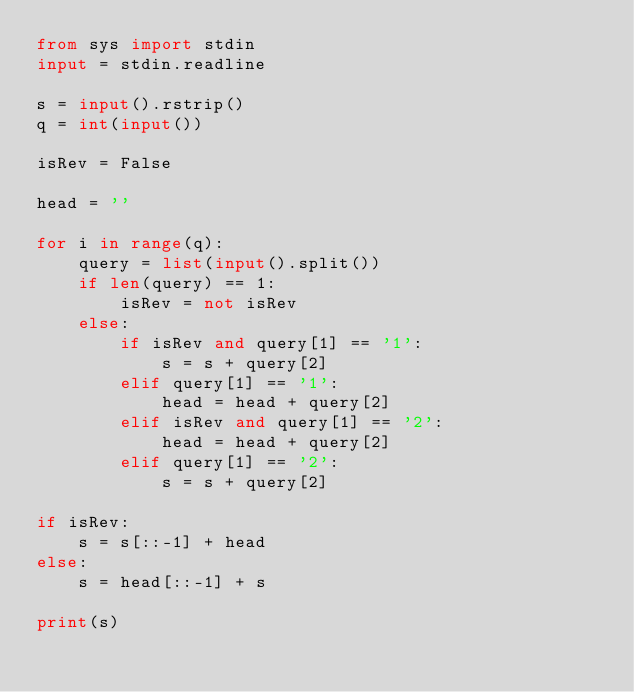Convert code to text. <code><loc_0><loc_0><loc_500><loc_500><_Python_>from sys import stdin
input = stdin.readline

s = input().rstrip()
q = int(input())

isRev = False

head = ''

for i in range(q):
    query = list(input().split())
    if len(query) == 1:
        isRev = not isRev
    else:
        if isRev and query[1] == '1':
            s = s + query[2]
        elif query[1] == '1':
            head = head + query[2]
        elif isRev and query[1] == '2':
            head = head + query[2]
        elif query[1] == '2':
            s = s + query[2]
            
if isRev:
    s = s[::-1] + head
else:
    s = head[::-1] + s
        
print(s)
        
</code> 